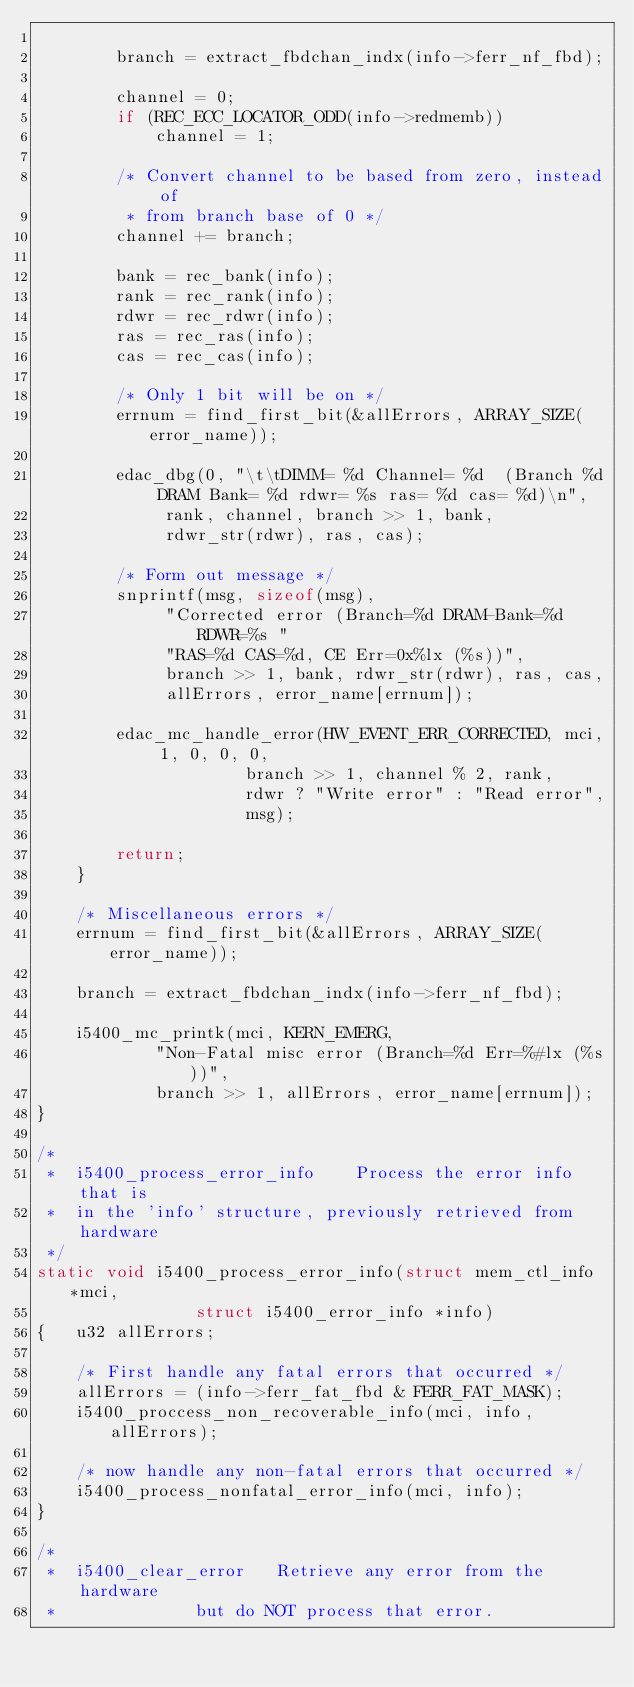Convert code to text. <code><loc_0><loc_0><loc_500><loc_500><_C_>
		branch = extract_fbdchan_indx(info->ferr_nf_fbd);

		channel = 0;
		if (REC_ECC_LOCATOR_ODD(info->redmemb))
			channel = 1;

		/* Convert channel to be based from zero, instead of
		 * from branch base of 0 */
		channel += branch;

		bank = rec_bank(info);
		rank = rec_rank(info);
		rdwr = rec_rdwr(info);
		ras = rec_ras(info);
		cas = rec_cas(info);

		/* Only 1 bit will be on */
		errnum = find_first_bit(&allErrors, ARRAY_SIZE(error_name));

		edac_dbg(0, "\t\tDIMM= %d Channel= %d  (Branch %d DRAM Bank= %d rdwr= %s ras= %d cas= %d)\n",
			 rank, channel, branch >> 1, bank,
			 rdwr_str(rdwr), ras, cas);

		/* Form out message */
		snprintf(msg, sizeof(msg),
			 "Corrected error (Branch=%d DRAM-Bank=%d RDWR=%s "
			 "RAS=%d CAS=%d, CE Err=0x%lx (%s))",
			 branch >> 1, bank, rdwr_str(rdwr), ras, cas,
			 allErrors, error_name[errnum]);

		edac_mc_handle_error(HW_EVENT_ERR_CORRECTED, mci, 1, 0, 0, 0,
				     branch >> 1, channel % 2, rank,
				     rdwr ? "Write error" : "Read error",
				     msg);

		return;
	}

	/* Miscellaneous errors */
	errnum = find_first_bit(&allErrors, ARRAY_SIZE(error_name));

	branch = extract_fbdchan_indx(info->ferr_nf_fbd);

	i5400_mc_printk(mci, KERN_EMERG,
			"Non-Fatal misc error (Branch=%d Err=%#lx (%s))",
			branch >> 1, allErrors, error_name[errnum]);
}

/*
 *	i5400_process_error_info	Process the error info that is
 *	in the 'info' structure, previously retrieved from hardware
 */
static void i5400_process_error_info(struct mem_ctl_info *mci,
				struct i5400_error_info *info)
{	u32 allErrors;

	/* First handle any fatal errors that occurred */
	allErrors = (info->ferr_fat_fbd & FERR_FAT_MASK);
	i5400_proccess_non_recoverable_info(mci, info, allErrors);

	/* now handle any non-fatal errors that occurred */
	i5400_process_nonfatal_error_info(mci, info);
}

/*
 *	i5400_clear_error	Retrieve any error from the hardware
 *				but do NOT process that error.</code> 